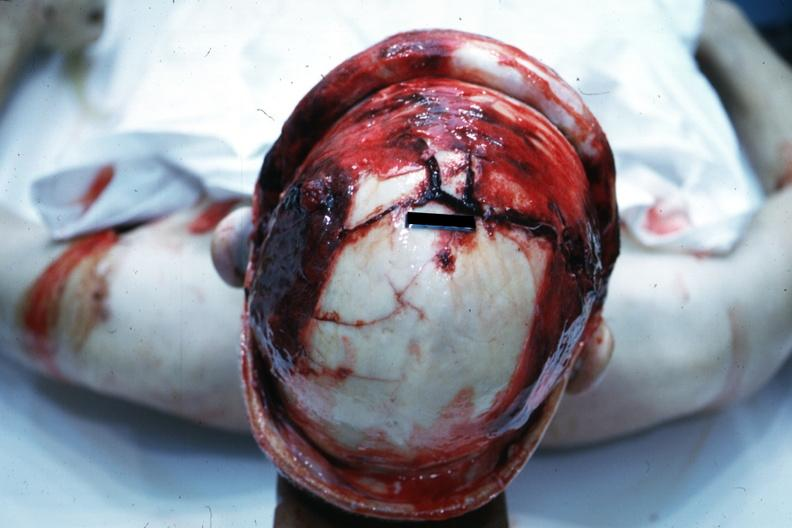s endocrine retracted to show massive fractures?
Answer the question using a single word or phrase. No 